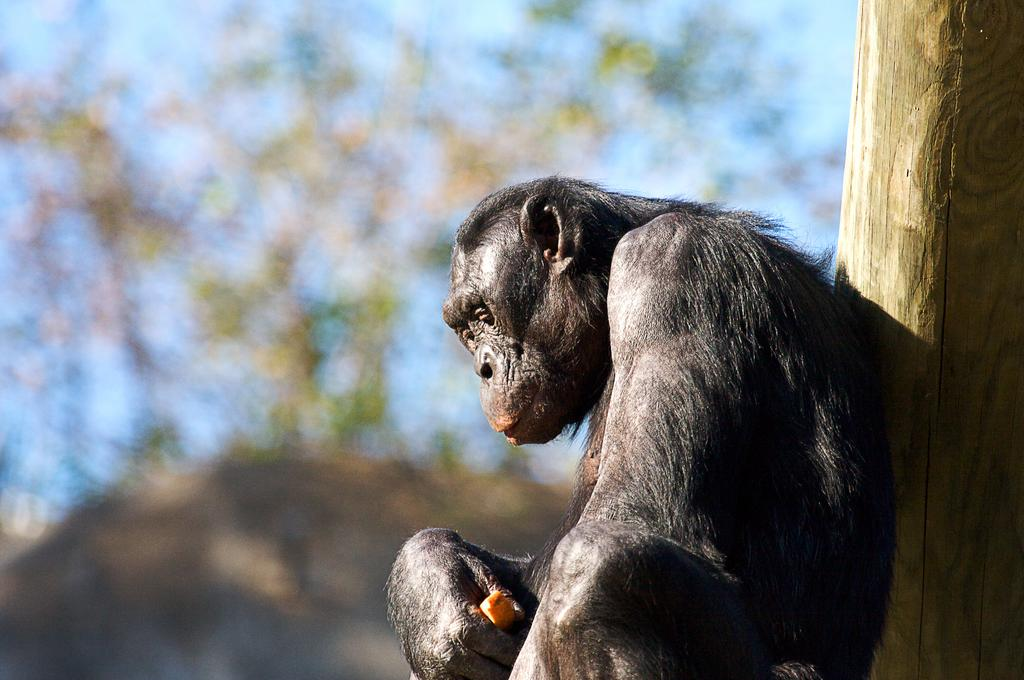What is the main subject of the image? There is a chimpanzee in the center of the image. What type of vegetation can be seen on the right side of the image? There is bamboo on the right side of the image. How many frogs are sitting on the table in the image? There is no table or frogs present in the image; it features a chimpanzee and bamboo. What type of writing instrument is the chimpanzee holding in the image? There is no writing instrument, such as a quill, present in the image. 